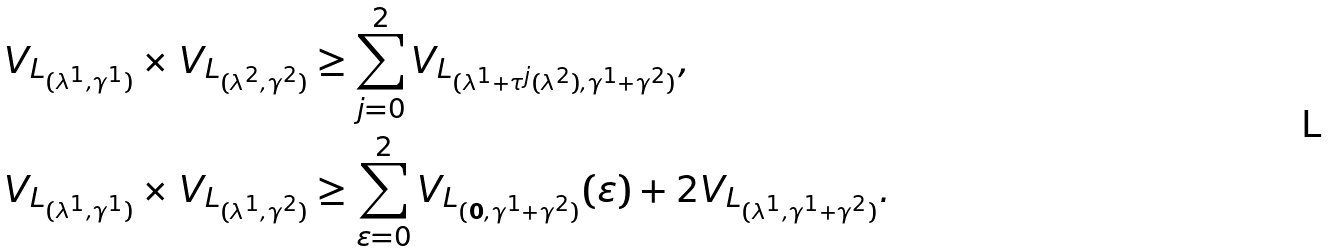<formula> <loc_0><loc_0><loc_500><loc_500>V _ { L _ { ( \lambda ^ { 1 } , \gamma ^ { 1 } ) } } \times V _ { L _ { ( \lambda ^ { 2 } , \gamma ^ { 2 } ) } } & \geq \sum _ { j = 0 } ^ { 2 } V _ { L _ { ( \lambda ^ { 1 } + \tau ^ { j } ( \lambda ^ { 2 } ) , \gamma ^ { 1 } + \gamma ^ { 2 } ) } } , \\ V _ { L _ { ( \lambda ^ { 1 } , \gamma ^ { 1 } ) } } \times V _ { L _ { ( \lambda ^ { 1 } , \gamma ^ { 2 } ) } } & \geq \sum _ { \varepsilon = 0 } ^ { 2 } V _ { L _ { ( { \mathbf 0 } , \gamma ^ { 1 } + \gamma ^ { 2 } ) } } ( \varepsilon ) + 2 V _ { L _ { ( \lambda ^ { 1 } , \gamma ^ { 1 } + \gamma ^ { 2 } ) } } .</formula> 